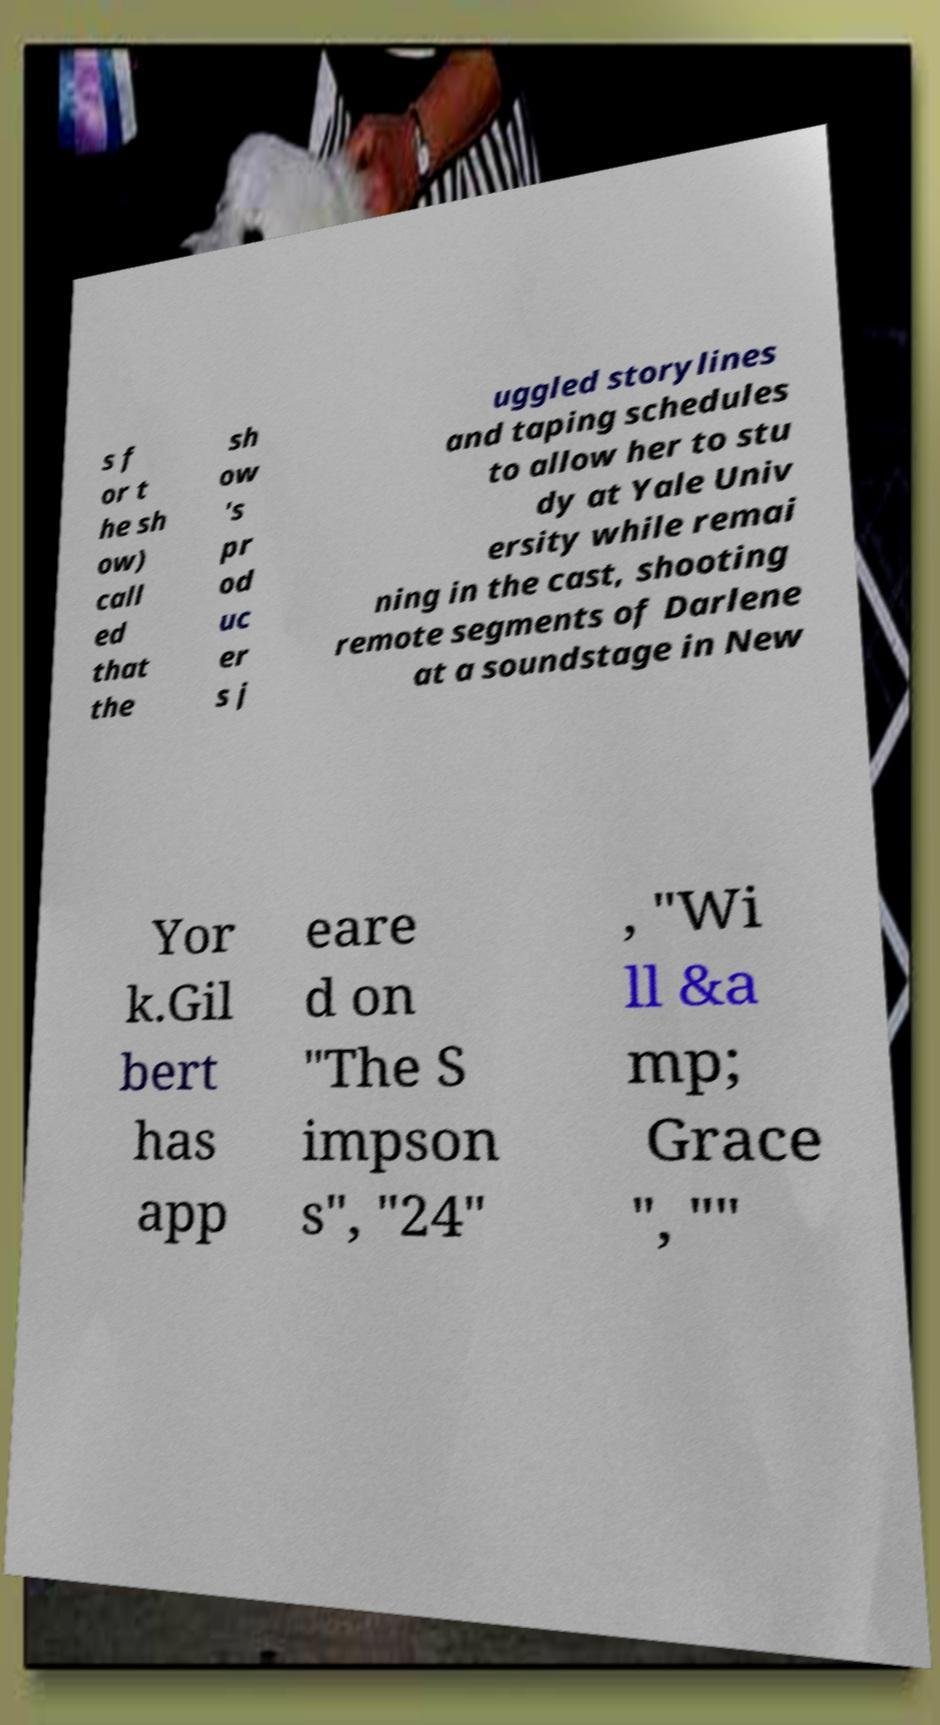Can you accurately transcribe the text from the provided image for me? s f or t he sh ow) call ed that the sh ow 's pr od uc er s j uggled storylines and taping schedules to allow her to stu dy at Yale Univ ersity while remai ning in the cast, shooting remote segments of Darlene at a soundstage in New Yor k.Gil bert has app eare d on "The S impson s", "24" , "Wi ll &a mp; Grace ", "" 